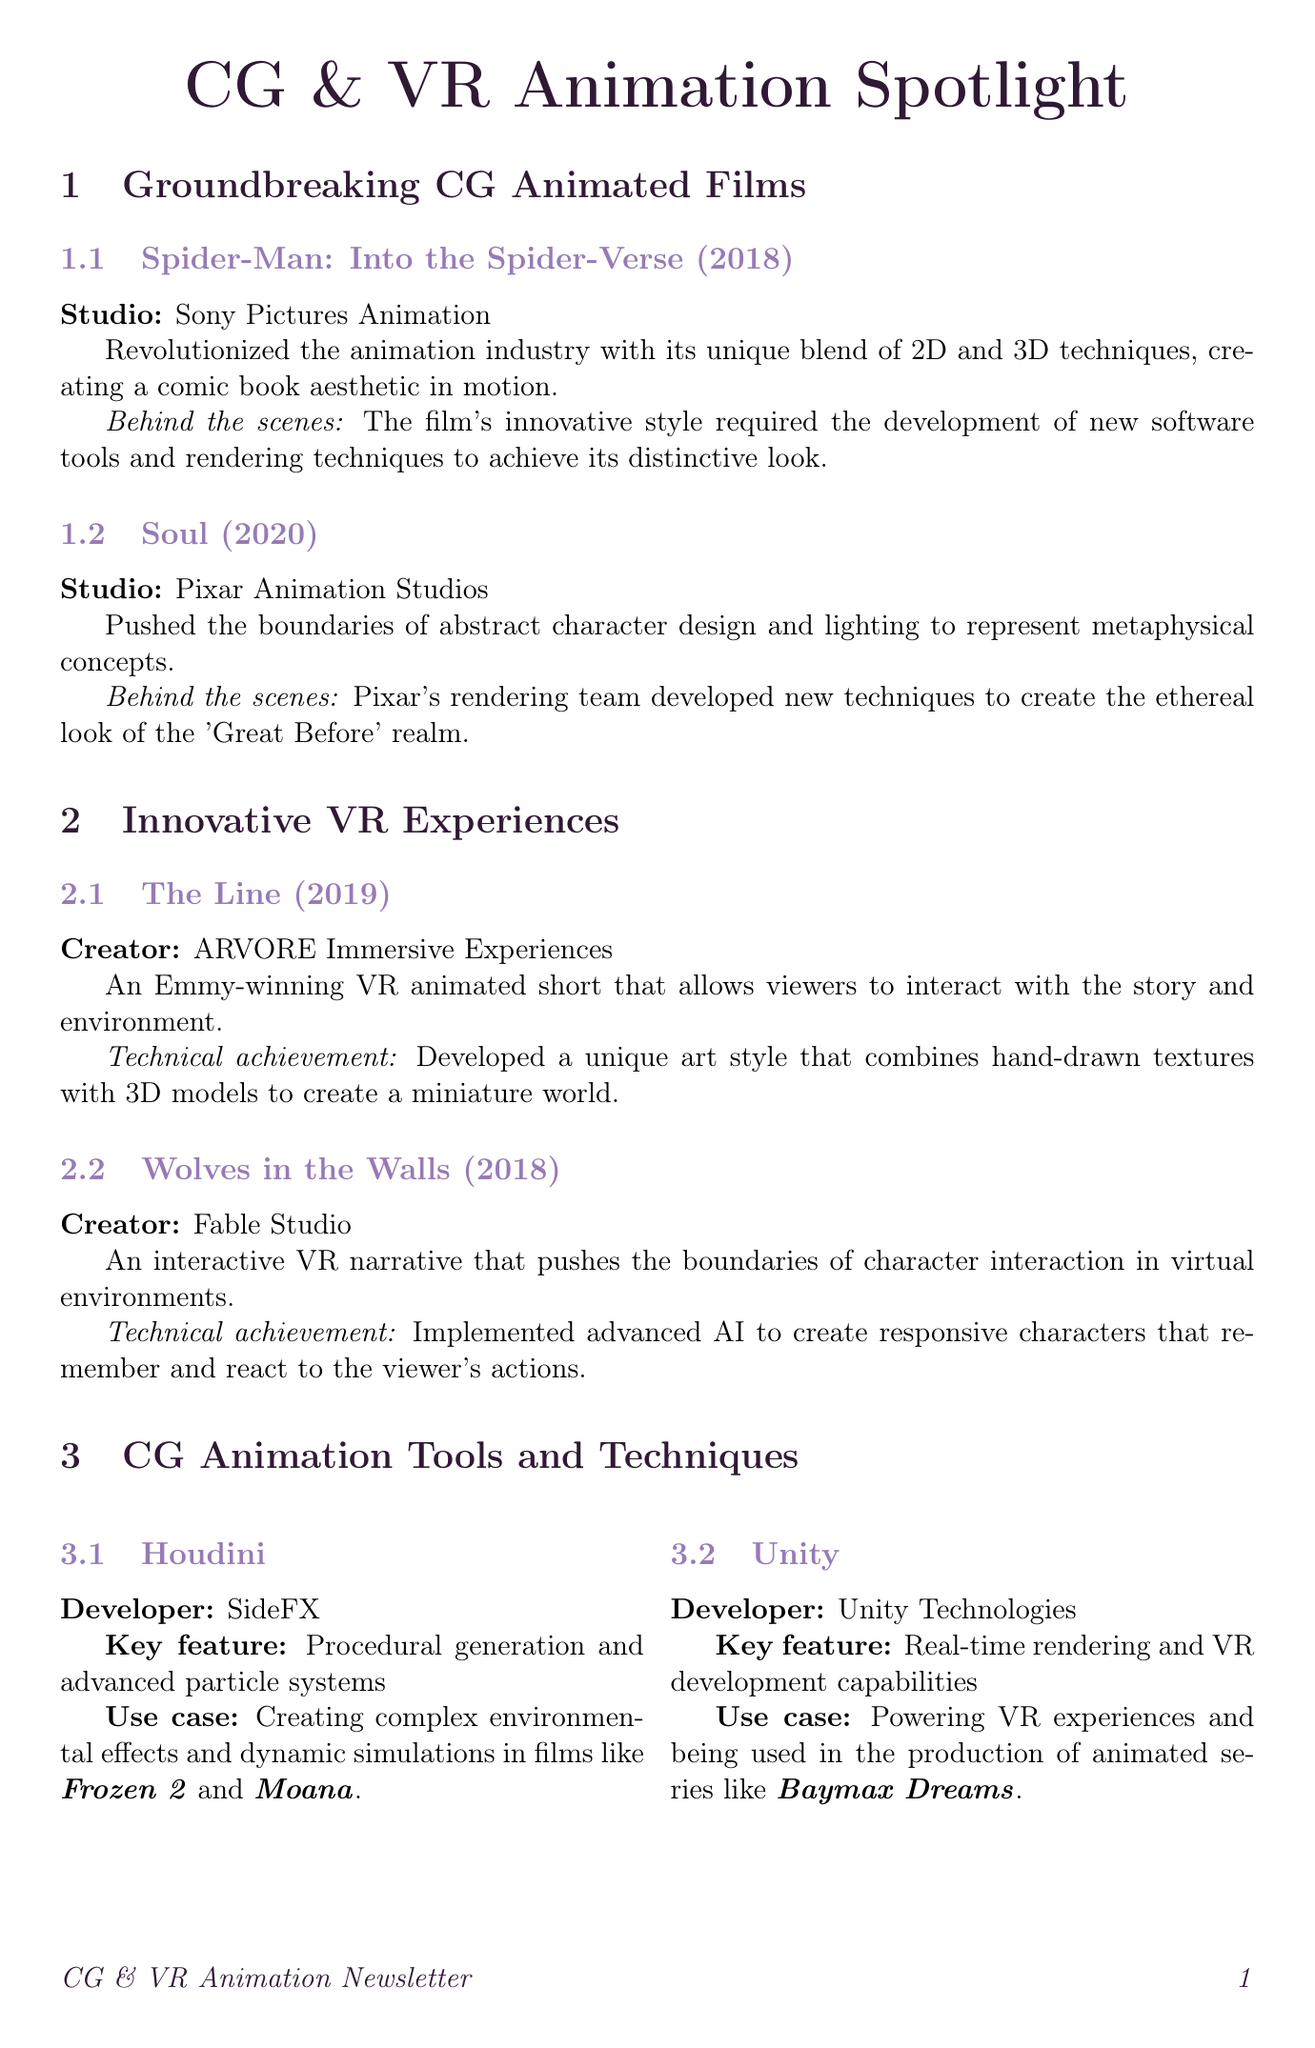what is the studio behind "Spider-Man: Into the Spider-Verse"? The document states that "Spider-Man: Into the Spider-Verse" was produced by Sony Pictures Animation.
Answer: Sony Pictures Animation what year was "Soul" released? The release year of "Soul", as mentioned in the document, is 2020.
Answer: 2020 who created "The Line"? The document identifies ARVORE Immersive Experiences as the creator of "The Line".
Answer: ARVORE Immersive Experiences what key feature does Houdini offer? According to the document, Houdini is known for its procedural generation and advanced particle systems.
Answer: Procedural generation and advanced particle systems which animation tool is used in the production of "Baymax Dreams"? The document specifies that Unity is used in the production of "Baymax Dreams".
Answer: Unity what trend is associated with Unreal Engine in film production? The document explains that the use of Unreal Engine in CG animation pipelines is growing, which allows for faster iteration and on-set visualization.
Answer: Real-time rendering in film production who is known for pioneering VR animation? The document states that Glen Keane is known for traditional Disney animation and pioneering VR animation.
Answer: Glen Keane what notable work is associated with Céline Desrumaux? The document mentions Céline Desrumaux as the Art Director for "The Little Prince" and "Back to the Moon" Google Doodle.
Answer: The Little Prince what is the main focus of the Artist Spotlight section? The document highlights the artists that contributed significantly to the field of CG and VR animation.
Answer: Significant artists in CG and VR animation 